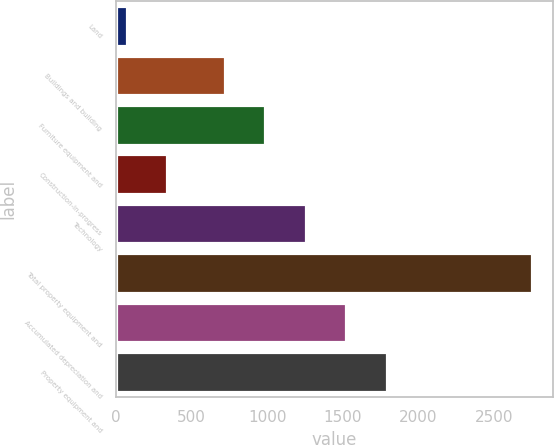<chart> <loc_0><loc_0><loc_500><loc_500><bar_chart><fcel>Land<fcel>Buildings and building<fcel>Furniture equipment and<fcel>Construction-in-progress<fcel>Technology<fcel>Total property equipment and<fcel>Accumulated depreciation and<fcel>Property equipment and<nl><fcel>71<fcel>719<fcel>986.8<fcel>338.8<fcel>1254.6<fcel>2749<fcel>1522.4<fcel>1790.2<nl></chart> 